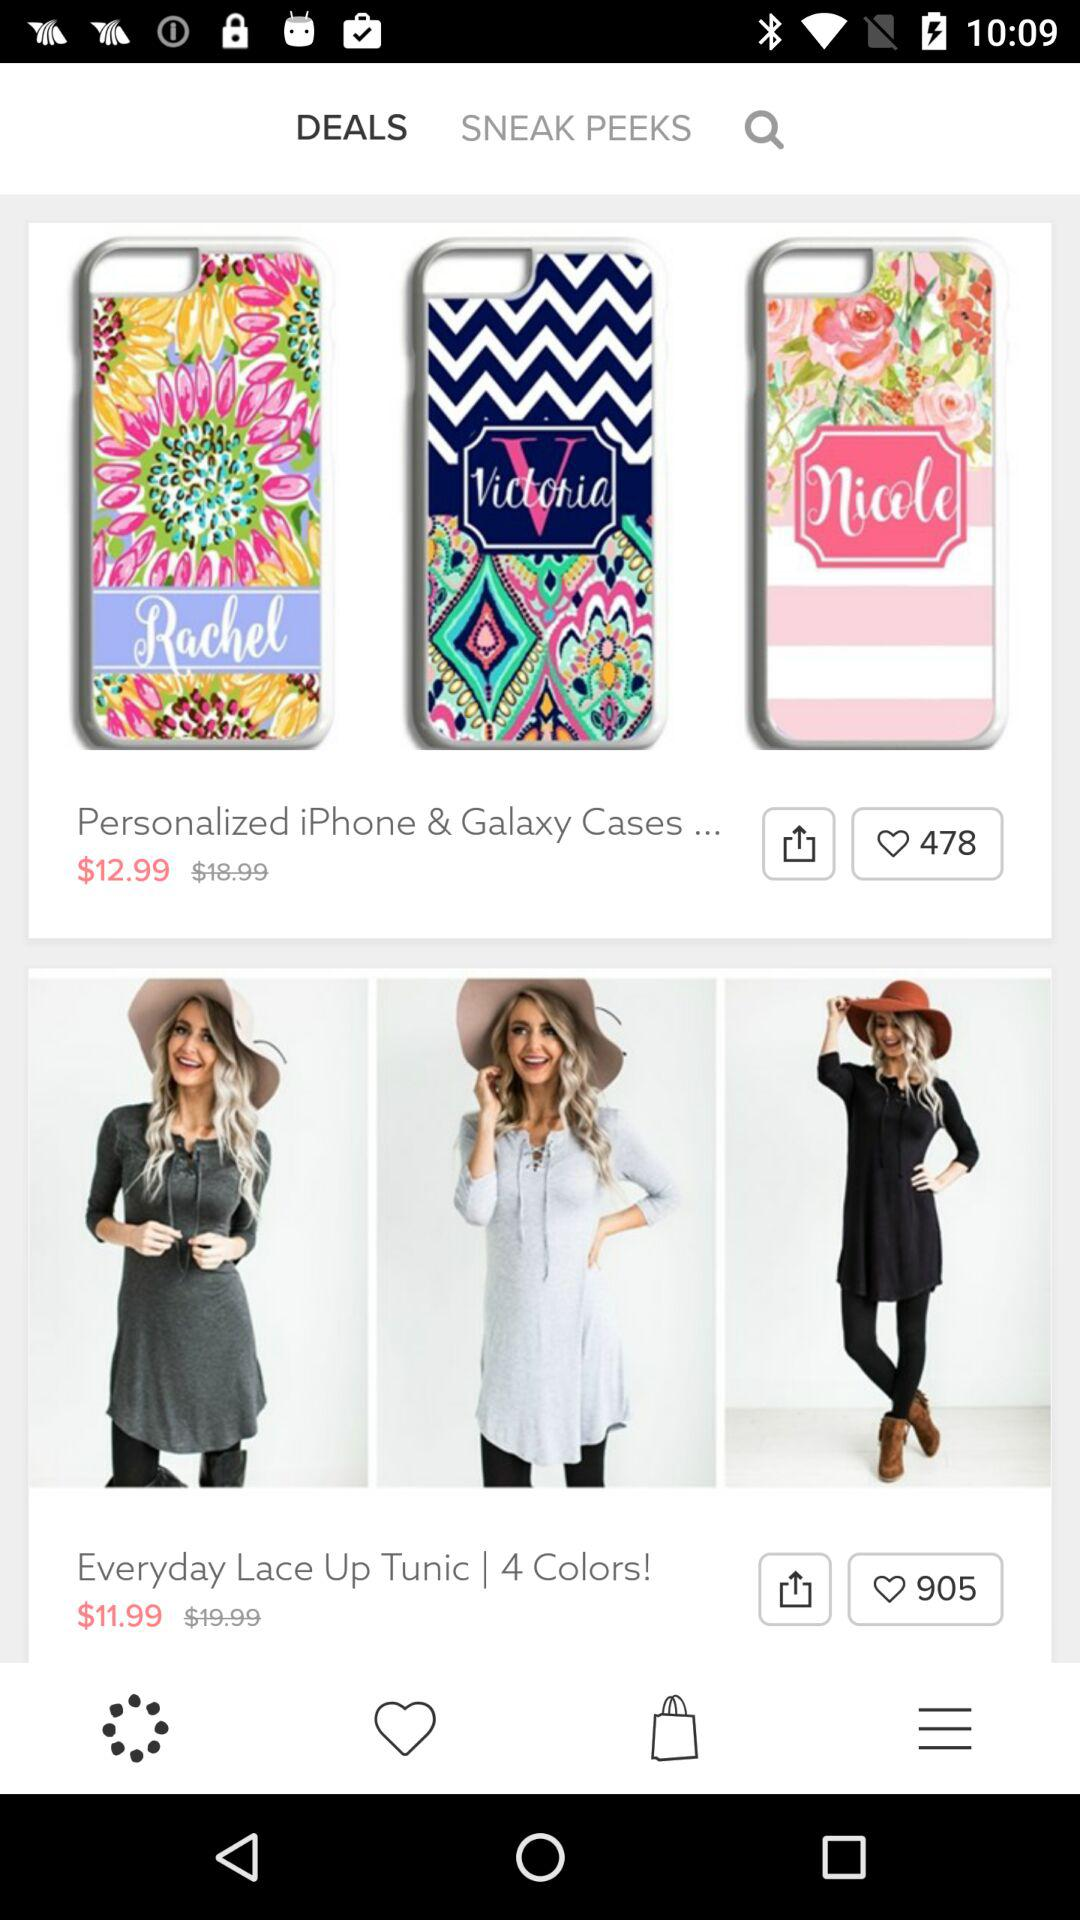How many colors are there for the "Everyday Lace Up Tunic"? There are 4 colors for the "Everyday Lace Up Tunic". 